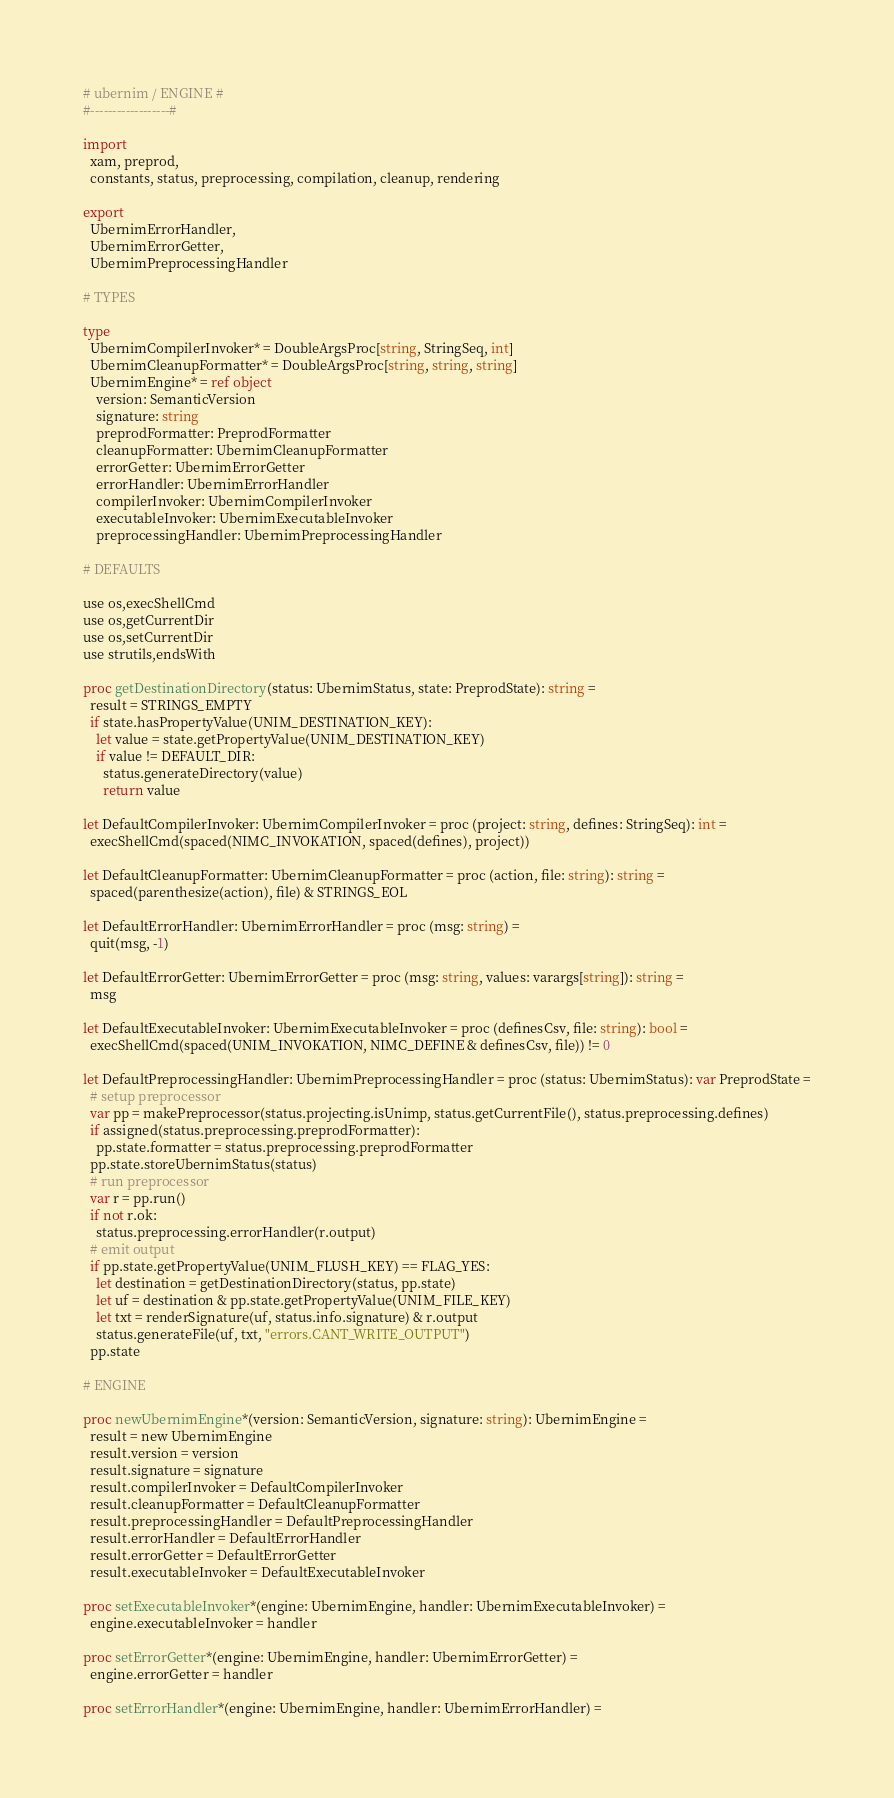Convert code to text. <code><loc_0><loc_0><loc_500><loc_500><_Nim_># ubernim / ENGINE #
#------------------#

import
  xam, preprod,
  constants, status, preprocessing, compilation, cleanup, rendering

export
  UbernimErrorHandler,
  UbernimErrorGetter,
  UbernimPreprocessingHandler

# TYPES

type
  UbernimCompilerInvoker* = DoubleArgsProc[string, StringSeq, int]
  UbernimCleanupFormatter* = DoubleArgsProc[string, string, string]
  UbernimEngine* = ref object
    version: SemanticVersion
    signature: string
    preprodFormatter: PreprodFormatter
    cleanupFormatter: UbernimCleanupFormatter
    errorGetter: UbernimErrorGetter
    errorHandler: UbernimErrorHandler
    compilerInvoker: UbernimCompilerInvoker
    executableInvoker: UbernimExecutableInvoker
    preprocessingHandler: UbernimPreprocessingHandler

# DEFAULTS

use os,execShellCmd
use os,getCurrentDir
use os,setCurrentDir
use strutils,endsWith

proc getDestinationDirectory(status: UbernimStatus, state: PreprodState): string =
  result = STRINGS_EMPTY
  if state.hasPropertyValue(UNIM_DESTINATION_KEY):
    let value = state.getPropertyValue(UNIM_DESTINATION_KEY)
    if value != DEFAULT_DIR:
      status.generateDirectory(value)
      return value

let DefaultCompilerInvoker: UbernimCompilerInvoker = proc (project: string, defines: StringSeq): int =
  execShellCmd(spaced(NIMC_INVOKATION, spaced(defines), project))

let DefaultCleanupFormatter: UbernimCleanupFormatter = proc (action, file: string): string =
  spaced(parenthesize(action), file) & STRINGS_EOL

let DefaultErrorHandler: UbernimErrorHandler = proc (msg: string) =
  quit(msg, -1)

let DefaultErrorGetter: UbernimErrorGetter = proc (msg: string, values: varargs[string]): string =
  msg

let DefaultExecutableInvoker: UbernimExecutableInvoker = proc (definesCsv, file: string): bool =
  execShellCmd(spaced(UNIM_INVOKATION, NIMC_DEFINE & definesCsv, file)) != 0

let DefaultPreprocessingHandler: UbernimPreprocessingHandler = proc (status: UbernimStatus): var PreprodState =
  # setup preprocessor
  var pp = makePreprocessor(status.projecting.isUnimp, status.getCurrentFile(), status.preprocessing.defines)
  if assigned(status.preprocessing.preprodFormatter):
    pp.state.formatter = status.preprocessing.preprodFormatter
  pp.state.storeUbernimStatus(status)
  # run preprocessor
  var r = pp.run()
  if not r.ok:
    status.preprocessing.errorHandler(r.output)
  # emit output
  if pp.state.getPropertyValue(UNIM_FLUSH_KEY) == FLAG_YES:
    let destination = getDestinationDirectory(status, pp.state)
    let uf = destination & pp.state.getPropertyValue(UNIM_FILE_KEY)
    let txt = renderSignature(uf, status.info.signature) & r.output
    status.generateFile(uf, txt, "errors.CANT_WRITE_OUTPUT")
  pp.state

# ENGINE

proc newUbernimEngine*(version: SemanticVersion, signature: string): UbernimEngine =
  result = new UbernimEngine
  result.version = version
  result.signature = signature
  result.compilerInvoker = DefaultCompilerInvoker
  result.cleanupFormatter = DefaultCleanupFormatter
  result.preprocessingHandler = DefaultPreprocessingHandler
  result.errorHandler = DefaultErrorHandler
  result.errorGetter = DefaultErrorGetter
  result.executableInvoker = DefaultExecutableInvoker

proc setExecutableInvoker*(engine: UbernimEngine, handler: UbernimExecutableInvoker) =
  engine.executableInvoker = handler

proc setErrorGetter*(engine: UbernimEngine, handler: UbernimErrorGetter) =
  engine.errorGetter = handler

proc setErrorHandler*(engine: UbernimEngine, handler: UbernimErrorHandler) =</code> 